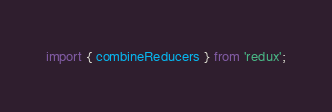<code> <loc_0><loc_0><loc_500><loc_500><_JavaScript_>import { combineReducers } from 'redux';</code> 